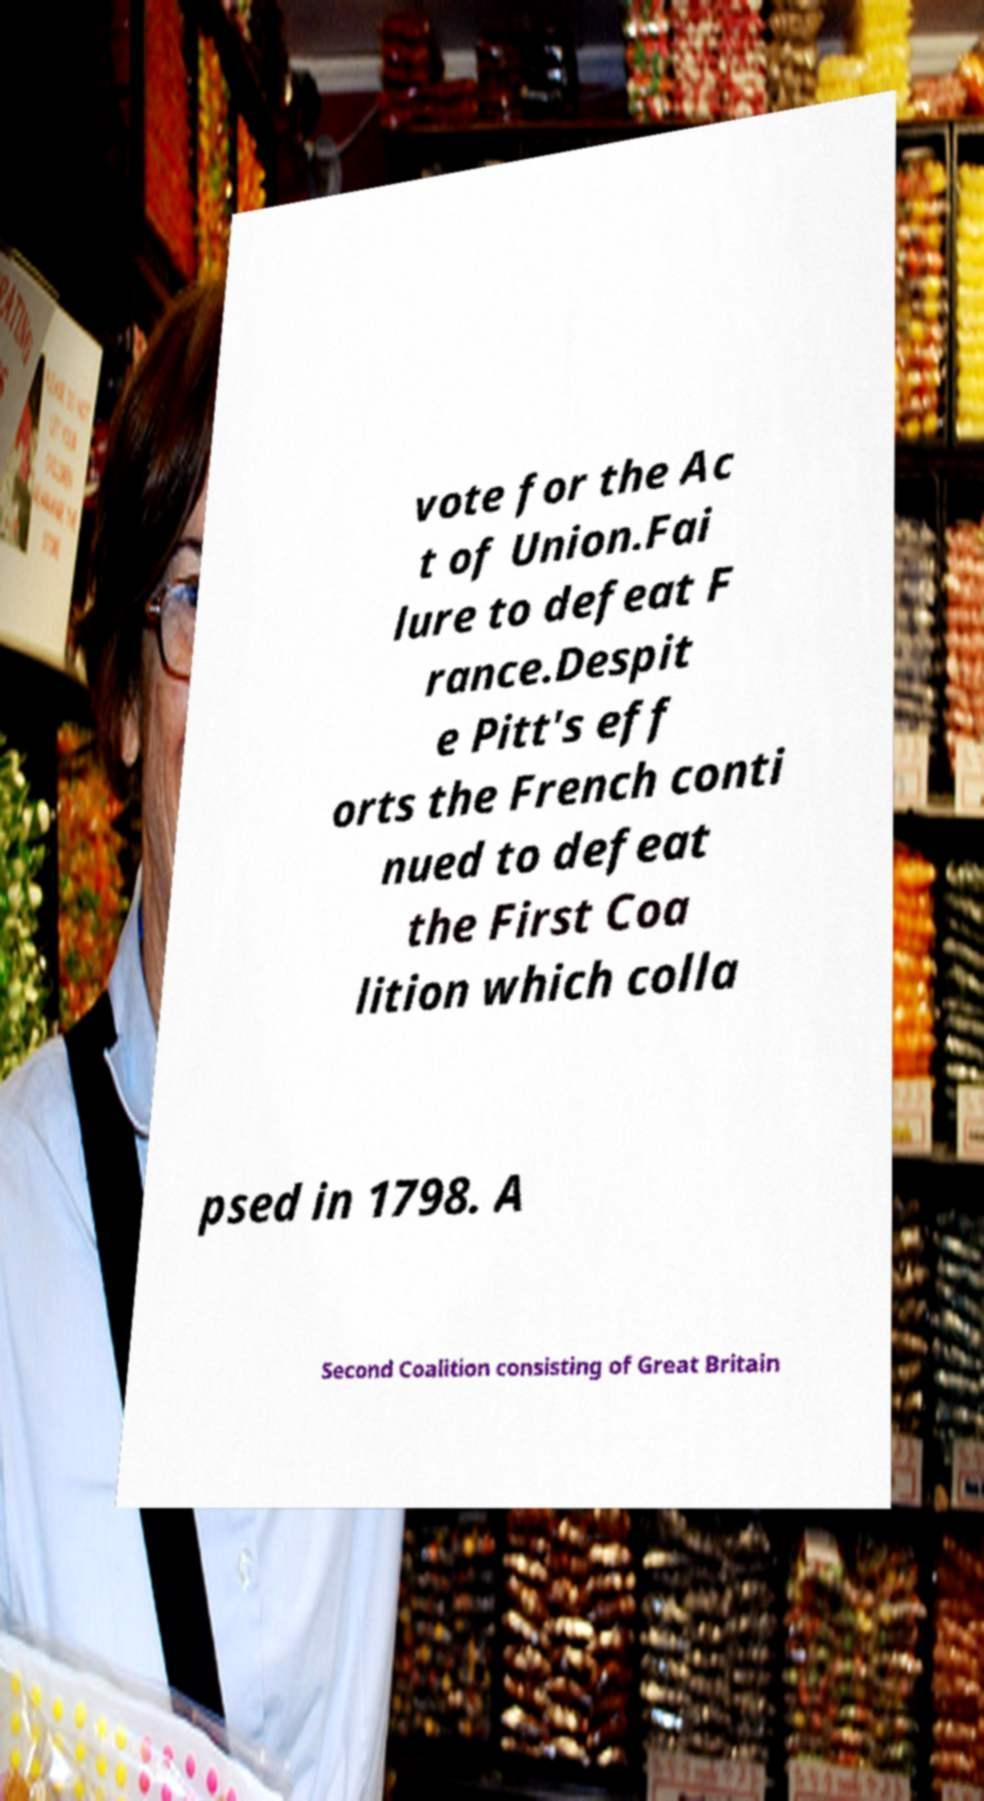Could you extract and type out the text from this image? vote for the Ac t of Union.Fai lure to defeat F rance.Despit e Pitt's eff orts the French conti nued to defeat the First Coa lition which colla psed in 1798. A Second Coalition consisting of Great Britain 